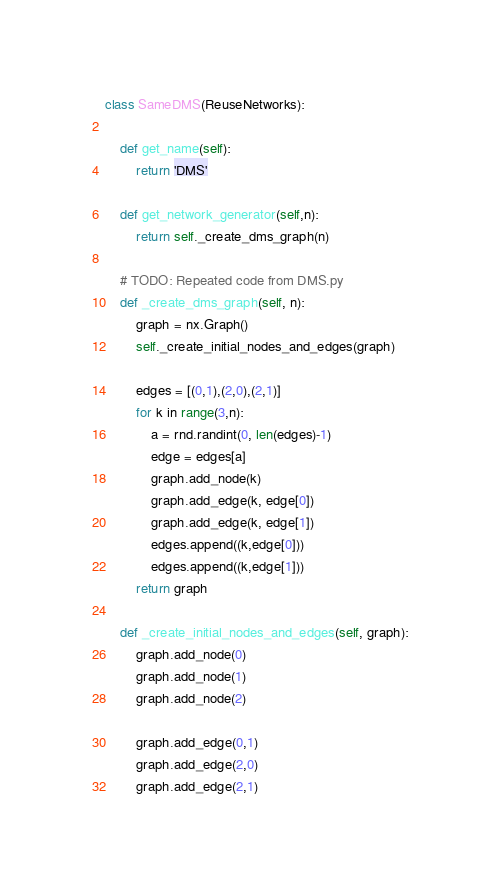<code> <loc_0><loc_0><loc_500><loc_500><_Python_>class SameDMS(ReuseNetworks):

    def get_name(self):
        return 'DMS'

    def get_network_generator(self,n):
        return self._create_dms_graph(n)

    # TODO: Repeated code from DMS.py
    def _create_dms_graph(self, n):
        graph = nx.Graph()
        self._create_initial_nodes_and_edges(graph)

        edges = [(0,1),(2,0),(2,1)]
        for k in range(3,n):
            a = rnd.randint(0, len(edges)-1)
            edge = edges[a]
            graph.add_node(k)
            graph.add_edge(k, edge[0])
            graph.add_edge(k, edge[1])
            edges.append((k,edge[0]))
            edges.append((k,edge[1]))
        return graph

    def _create_initial_nodes_and_edges(self, graph):
        graph.add_node(0)
        graph.add_node(1)
        graph.add_node(2)

        graph.add_edge(0,1)
        graph.add_edge(2,0)
        graph.add_edge(2,1)</code> 